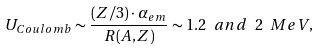<formula> <loc_0><loc_0><loc_500><loc_500>U _ { C o u l o m b } \sim \frac { ( Z / 3 ) \cdot \alpha _ { e m } } { R ( A , Z ) } \sim 1 . 2 \ a n d \ 2 \ M e V ,</formula> 